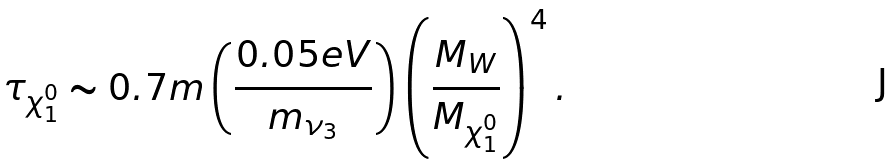Convert formula to latex. <formula><loc_0><loc_0><loc_500><loc_500>\tau _ { \chi _ { 1 } ^ { 0 } } \sim 0 . 7 m \left ( \frac { 0 . 0 5 e V } { m _ { \nu _ { 3 } } } \right ) \left ( \frac { M _ { W } } { M _ { \chi _ { 1 } ^ { 0 } } } \right ) ^ { 4 } .</formula> 